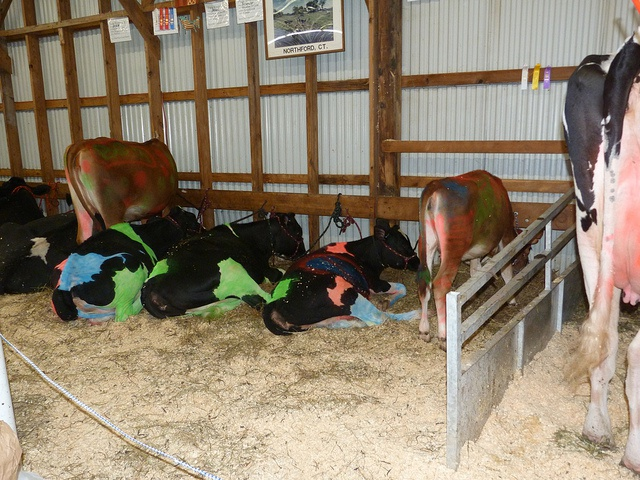Describe the objects in this image and their specific colors. I can see cow in black, lightgray, lightpink, and gray tones, cow in black, darkgray, maroon, and gray tones, cow in black, lightgreen, and gray tones, cow in black, maroon, and gray tones, and cow in black, green, teal, and olive tones in this image. 